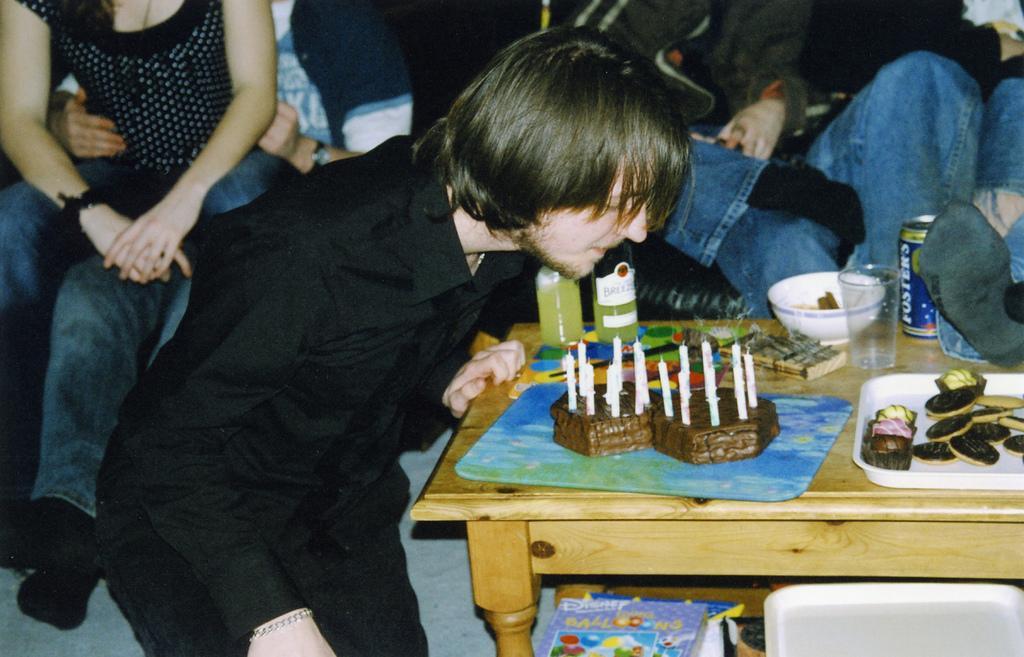In one or two sentences, can you explain what this image depicts? A boy i s blowing off candles on his birthday cake. 